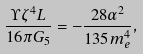Convert formula to latex. <formula><loc_0><loc_0><loc_500><loc_500>\frac { \Upsilon \zeta ^ { 4 } L } { 1 6 \pi G _ { 5 } } = - \frac { 2 8 \alpha ^ { 2 } } { 1 3 5 m _ { e } ^ { 4 } } ,</formula> 